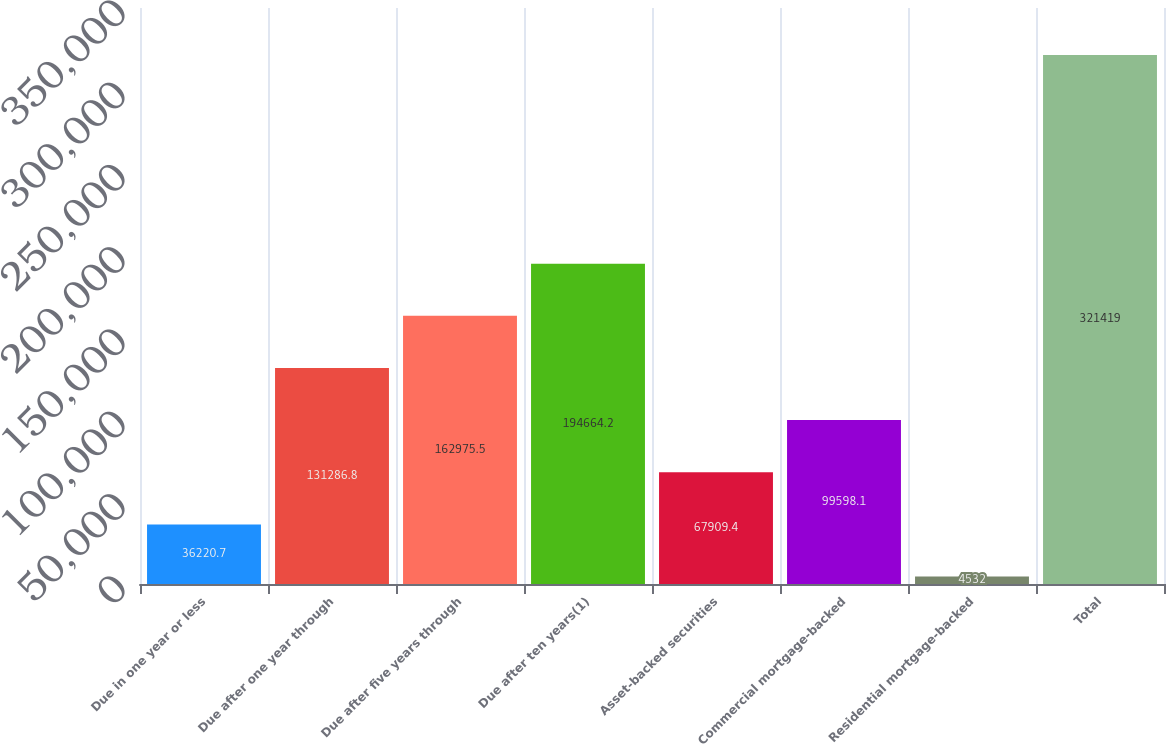<chart> <loc_0><loc_0><loc_500><loc_500><bar_chart><fcel>Due in one year or less<fcel>Due after one year through<fcel>Due after five years through<fcel>Due after ten years(1)<fcel>Asset-backed securities<fcel>Commercial mortgage-backed<fcel>Residential mortgage-backed<fcel>Total<nl><fcel>36220.7<fcel>131287<fcel>162976<fcel>194664<fcel>67909.4<fcel>99598.1<fcel>4532<fcel>321419<nl></chart> 